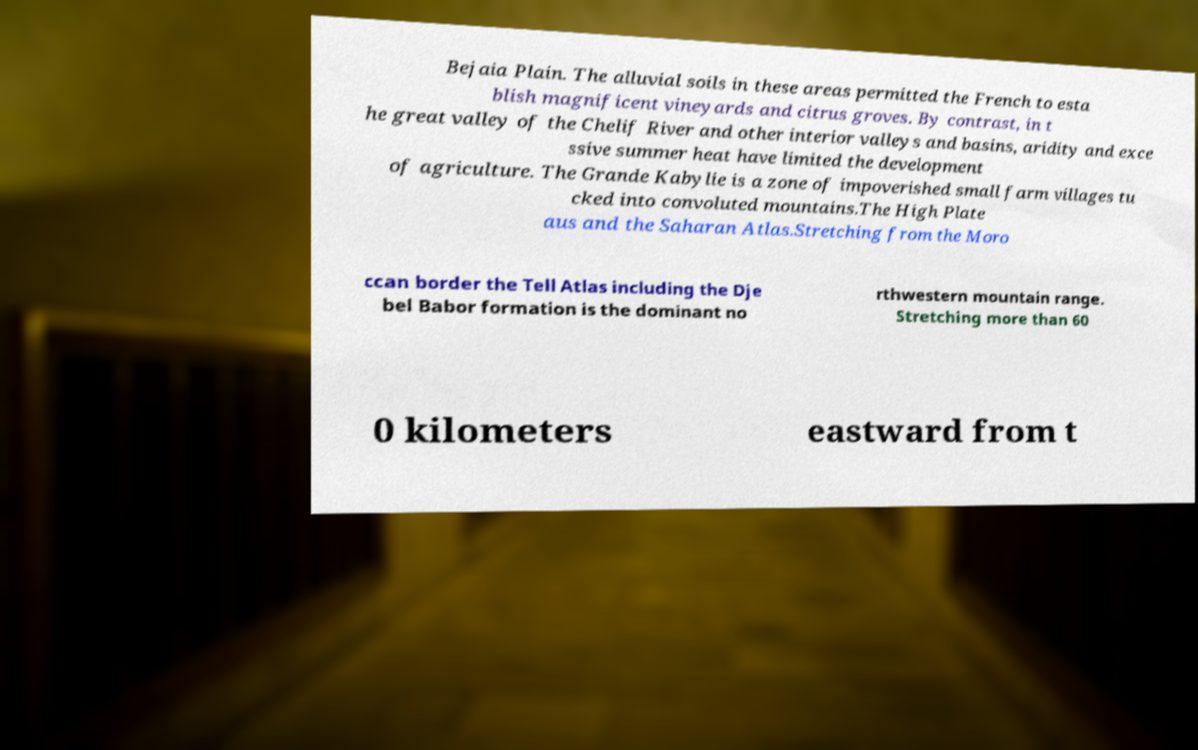Please identify and transcribe the text found in this image. Bejaia Plain. The alluvial soils in these areas permitted the French to esta blish magnificent vineyards and citrus groves. By contrast, in t he great valley of the Chelif River and other interior valleys and basins, aridity and exce ssive summer heat have limited the development of agriculture. The Grande Kabylie is a zone of impoverished small farm villages tu cked into convoluted mountains.The High Plate aus and the Saharan Atlas.Stretching from the Moro ccan border the Tell Atlas including the Dje bel Babor formation is the dominant no rthwestern mountain range. Stretching more than 60 0 kilometers eastward from t 